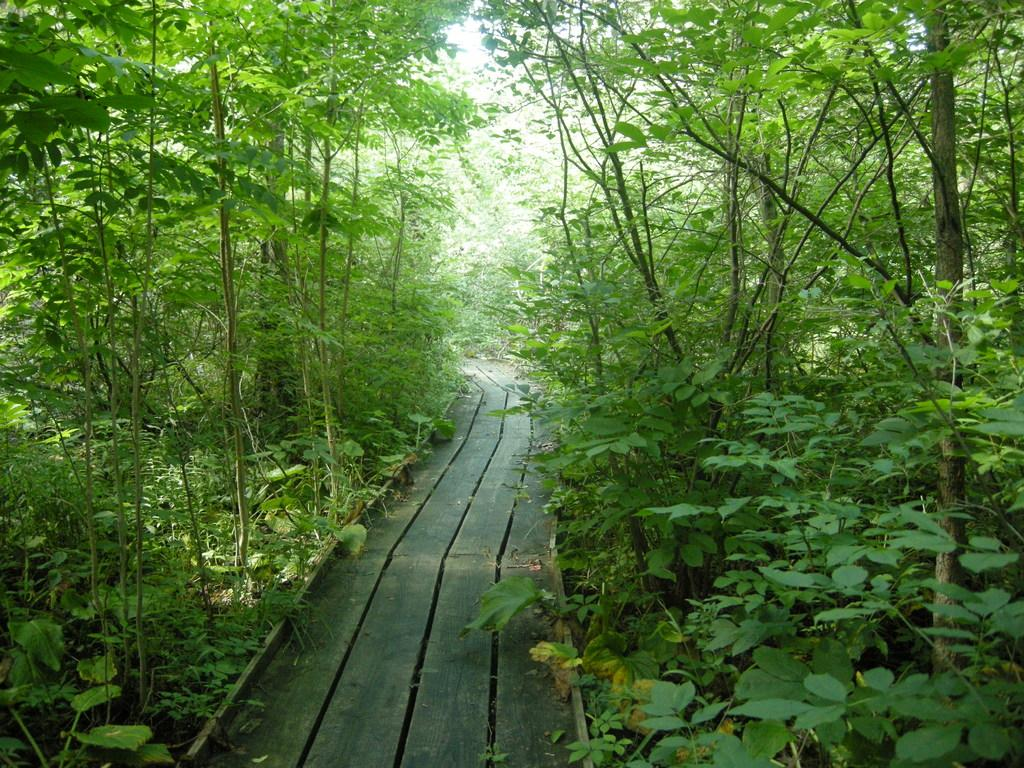What type of living organisms can be seen in the image? Plants and trees are visible in the image. What is the wooden structure in the image used for? There is a wooden walkway in the image. How does the love and comfort provided by the plants and trees in the image affect the people nearby? There is no indication in the image of people being affected by love and comfort provided by the plants and trees, as the image only shows the plants, trees, and wooden walkway. 